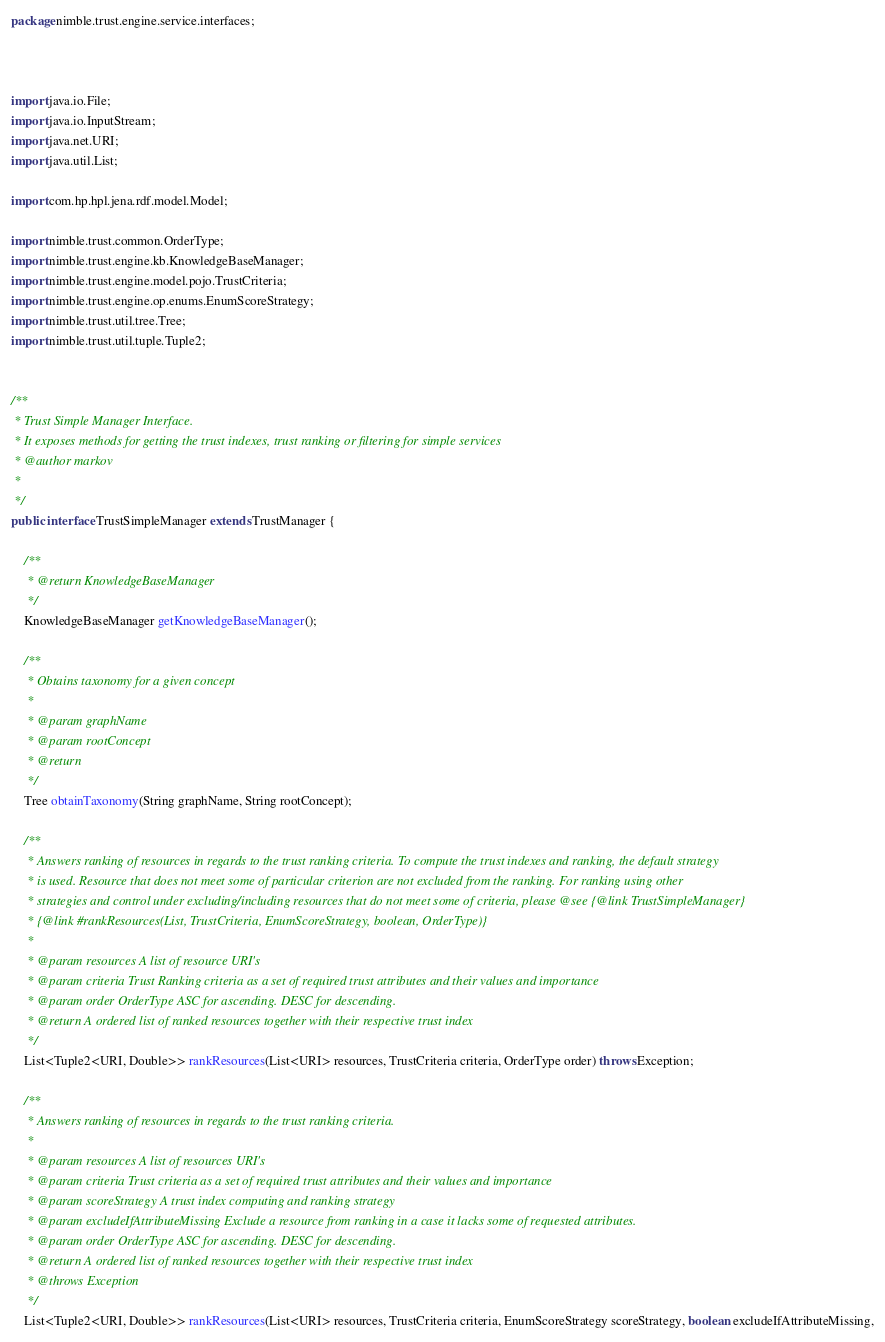<code> <loc_0><loc_0><loc_500><loc_500><_Java_>package nimble.trust.engine.service.interfaces;



import java.io.File;
import java.io.InputStream;
import java.net.URI;
import java.util.List;

import com.hp.hpl.jena.rdf.model.Model;

import nimble.trust.common.OrderType;
import nimble.trust.engine.kb.KnowledgeBaseManager;
import nimble.trust.engine.model.pojo.TrustCriteria;
import nimble.trust.engine.op.enums.EnumScoreStrategy;
import nimble.trust.util.tree.Tree;
import nimble.trust.util.tuple.Tuple2;


/**
 * Trust Simple Manager Interface. 
 * It exposes methods for getting the trust indexes, trust ranking or filtering for simple services
 * @author markov
 *
 */
public interface TrustSimpleManager extends TrustManager {

	/**
	 * @return KnowledgeBaseManager
	 */
	KnowledgeBaseManager getKnowledgeBaseManager();

	/**
	 * Obtains taxonomy for a given concept
	 * 
	 * @param graphName
	 * @param rootConcept
	 * @return
	 */
	Tree obtainTaxonomy(String graphName, String rootConcept);

	/**
	 * Answers ranking of resources in regards to the trust ranking criteria. To compute the trust indexes and ranking, the default strategy
	 * is used. Resource that does not meet some of particular criterion are not excluded from the ranking. For ranking using other
	 * strategies and control under excluding/including resources that do not meet some of criteria, please @see {@link TrustSimpleManager}
	 * {@link #rankResources(List, TrustCriteria, EnumScoreStrategy, boolean, OrderType)}
	 * 
	 * @param resources A list of resource URI's
	 * @param criteria Trust Ranking criteria as a set of required trust attributes and their values and importance
	 * @param order OrderType ASC for ascending. DESC for descending.
	 * @return A ordered list of ranked resources together with their respective trust index
	 */
	List<Tuple2<URI, Double>> rankResources(List<URI> resources, TrustCriteria criteria, OrderType order) throws Exception;

	/**
	 * Answers ranking of resources in regards to the trust ranking criteria.
	 * 
	 * @param resources A list of resources URI's
	 * @param criteria Trust criteria as a set of required trust attributes and their values and importance
	 * @param scoreStrategy A trust index computing and ranking strategy
	 * @param excludeIfAttributeMissing Exclude a resource from ranking in a case it lacks some of requested attributes.
	 * @param order OrderType ASC for ascending. DESC for descending.
	 * @return A ordered list of ranked resources together with their respective trust index
	 * @throws Exception
	 */
	List<Tuple2<URI, Double>> rankResources(List<URI> resources, TrustCriteria criteria, EnumScoreStrategy scoreStrategy, boolean excludeIfAttributeMissing,</code> 